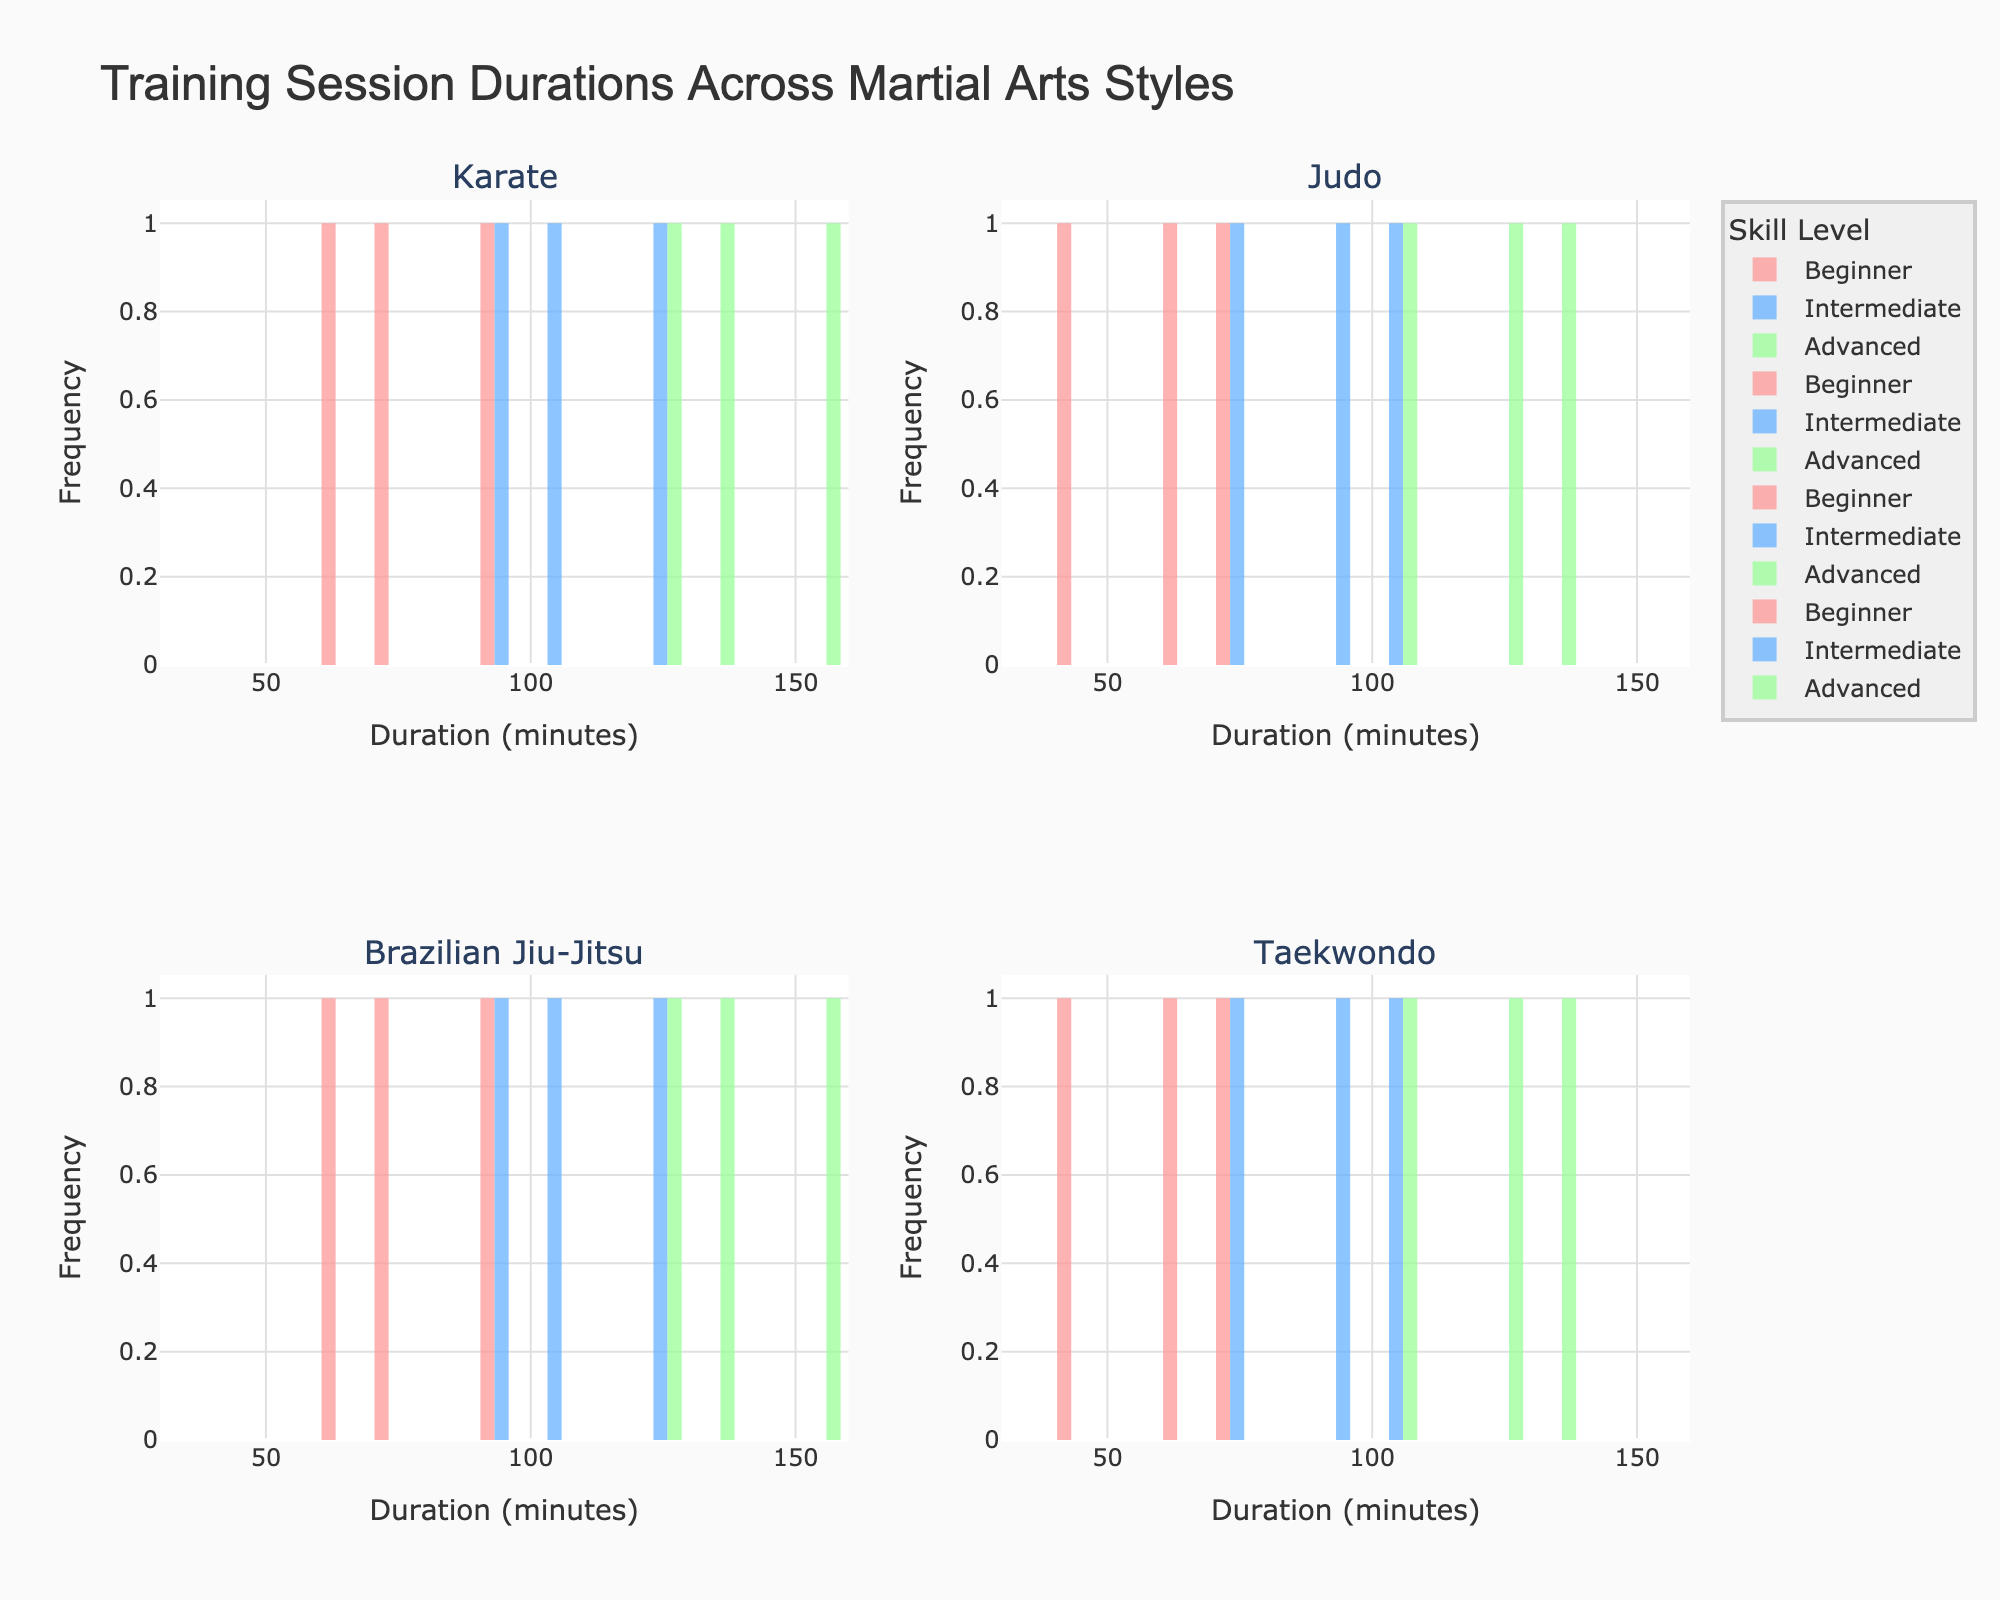How many different martial arts styles are represented in the figure? There are four subplot titles in the figure, each representing a different martial arts style: Karate, Judo, Brazilian Jiu-Jitsu, and Taekwondo.
Answer: 4 Which level in Karate has the highest frequency of training sessions lasting 120 minutes? By looking at the histogram for Karate, you can see that the Advanced level has the highest bar for the 120 minutes duration, indicating the highest frequency.
Answer: Advanced What is the range of training session durations for Judo across all levels? Observing the histogram for Judo, the durations span from 45 minutes to 135 minutes. This includes multiple bins for Beginners, Intermediates, and Advanced levels.
Answer: 45 to 135 minutes How does the most common duration for Beginner Taekwondo sessions compare to the most common duration for Beginner Judo sessions? In Beginner Taekwondo, the most common duration is 45 minutes, while for Beginner Judo it is 60 minutes. You can see this by identifying the tallest bars in the respective histograms.
Answer: 45 minutes for Taekwondo, 60 minutes for Judo Which martial arts style shows the highest frequency of 150-minute training sessions at the Advanced level? The histogram for Brazilian Jiu-Jitsu shows a bar at 150 minutes at the Advanced level, but the histogram for Karate shows a higher frequency at 150 minutes in the Advanced level.
Answer: Karate What's the average duration of Intermediate level sessions across all martial arts styles? Calculate the average by summing up the Intermediate session durations for each martial art and dividing by the number of values. The values are: Karate (90, 105, 120), Judo (75, 90, 105), Brazilian Jiu-Jitsu (90, 105, 120), Taekwondo (75, 90, 105). The sum is 1050 and there are 12 values. 1050 / 12 = 87.5 minutes.
Answer: 87.5 minutes Which martial arts style has the narrowest range of session durations for the Advanced level? Compare the range of durations shown in the histograms for Advanced sessions. Karate ranges from 120 to 150, Judo ranges from 105 to 135, Brazilian Jiu-Jitsu from 120 to 150, and Taekwondo from 105 to 135. Judo and Taekwondo have the narrowest range (30 minutes).
Answer: Judo and Taekwondo How many 105-minute sessions are there at the Intermediate level across all martial arts styles? Sum the frequency of 105-minute bars for Intermediate levels in all four histograms. Karate has 1, Judo has 1, Brazilian Jiu-Jitsu has 1, and Taekwondo has 1 for 105 minutes. 1 + 1 + 1 + 1 = 4.
Answer: 4 